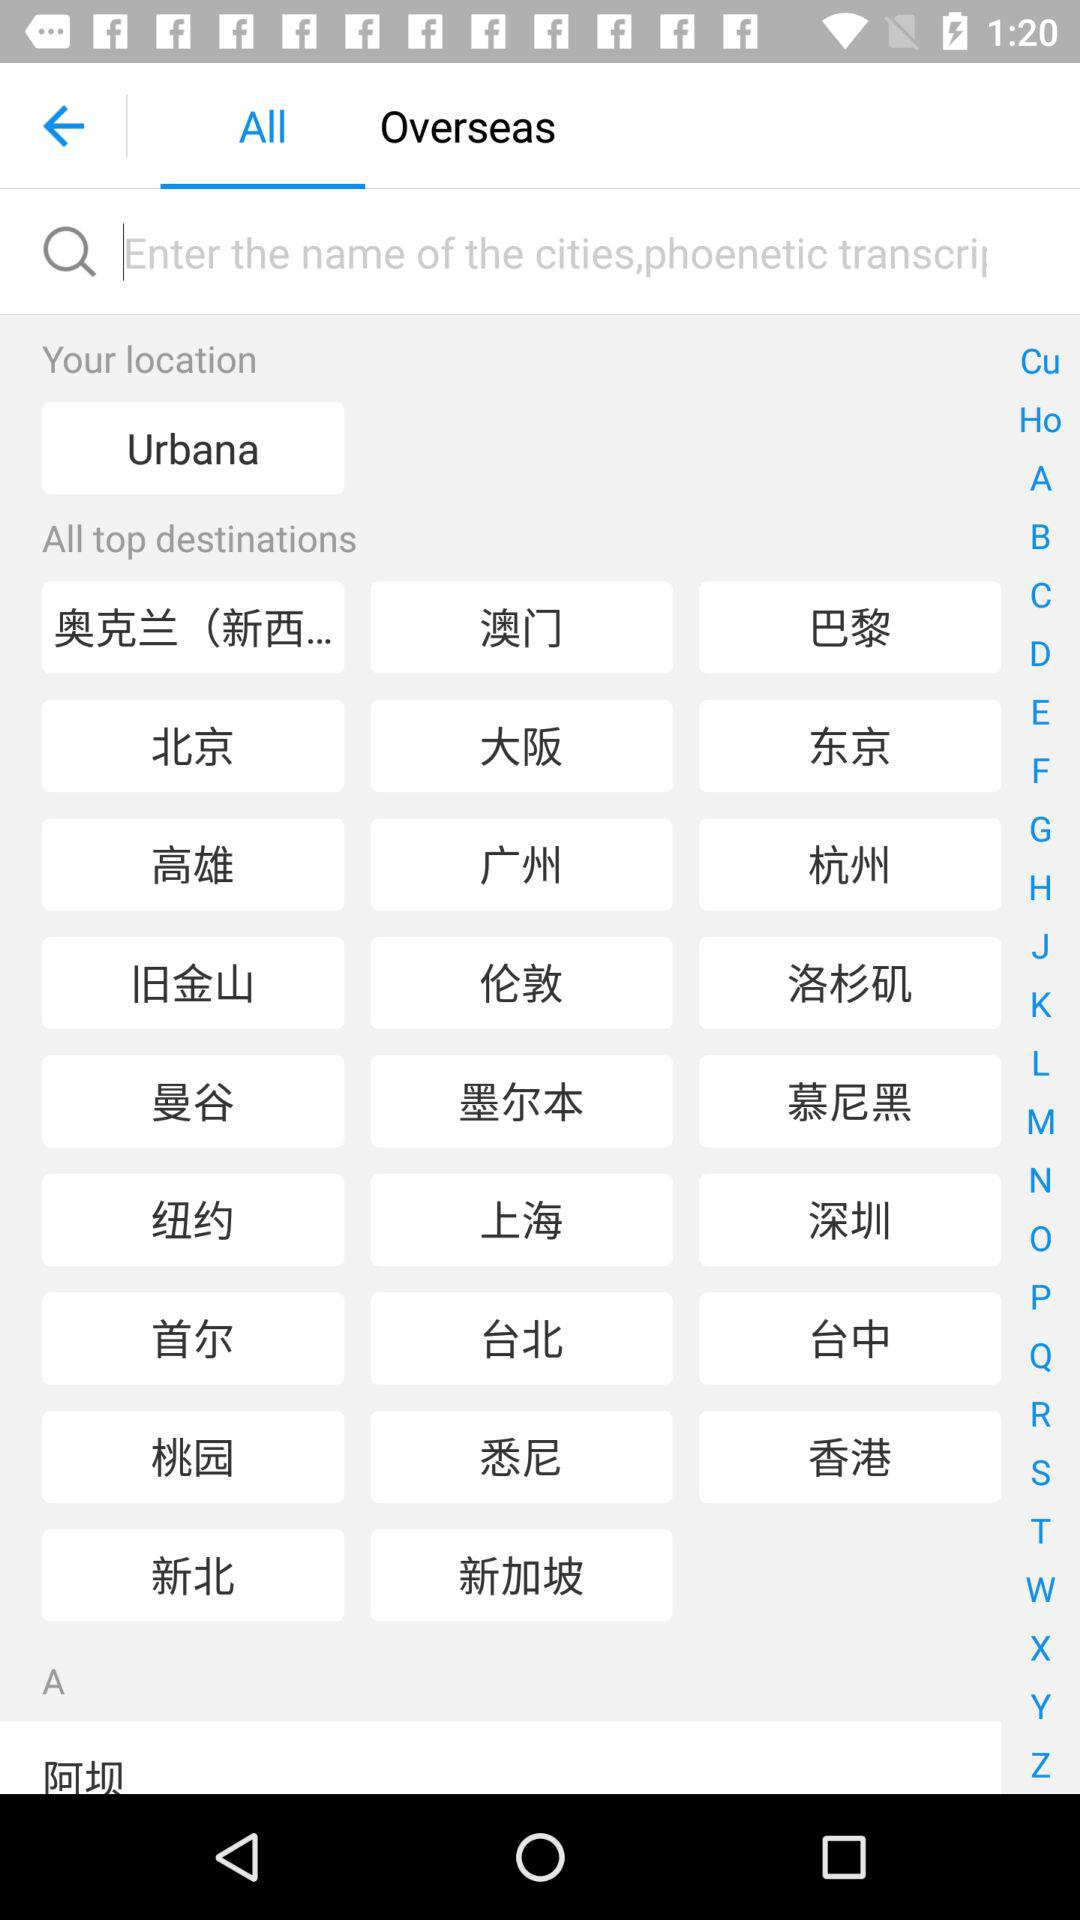Which language was chosen?
When the provided information is insufficient, respond with <no answer>. <no answer> 